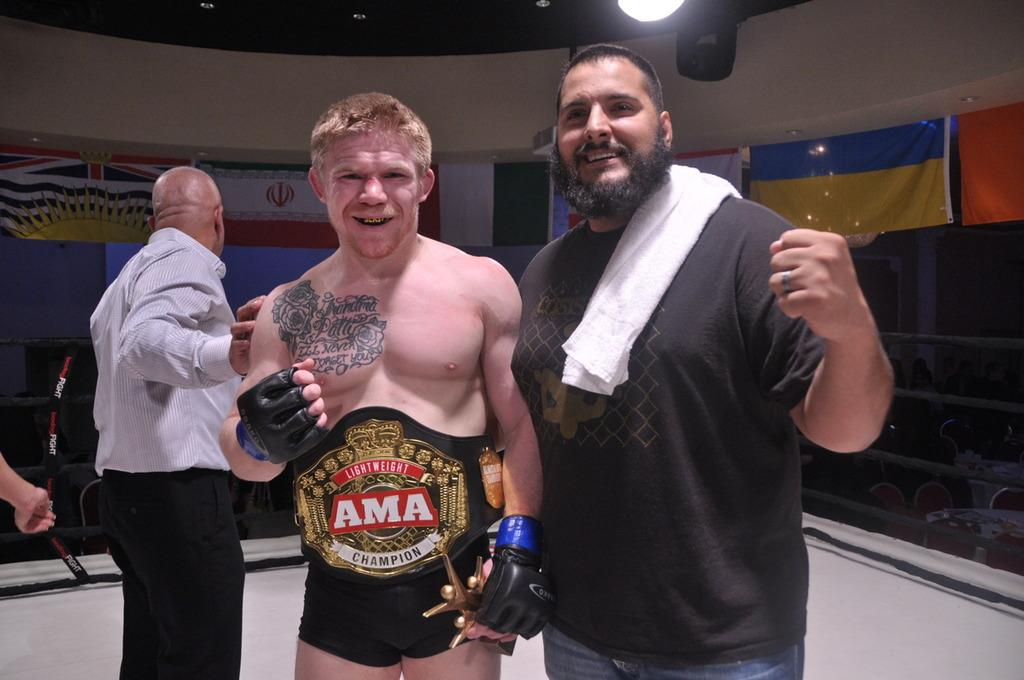<image>
Share a concise interpretation of the image provided. a team member who is the ama champion wears leather gloves 